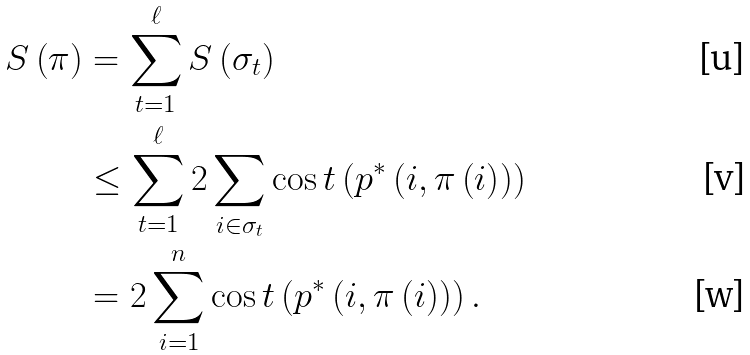Convert formula to latex. <formula><loc_0><loc_0><loc_500><loc_500>S \left ( \pi \right ) & = \sum _ { t = 1 } ^ { \ell } S \left ( \sigma _ { t } \right ) \\ & \leq \sum _ { t = 1 } ^ { \ell } 2 \sum _ { i \in \sigma _ { t } } \cos t \left ( p ^ { * } \left ( i , \pi \left ( i \right ) \right ) \right ) \\ & = 2 \sum _ { i = 1 } ^ { n } \cos t \left ( p ^ { * } \left ( i , \pi \left ( i \right ) \right ) \right ) .</formula> 